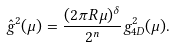<formula> <loc_0><loc_0><loc_500><loc_500>\hat { g } ^ { 2 } ( \mu ) = \frac { ( 2 \pi R \mu ) ^ { \delta } } { 2 ^ { n } } g _ { 4 D } ^ { 2 } ( \mu ) .</formula> 